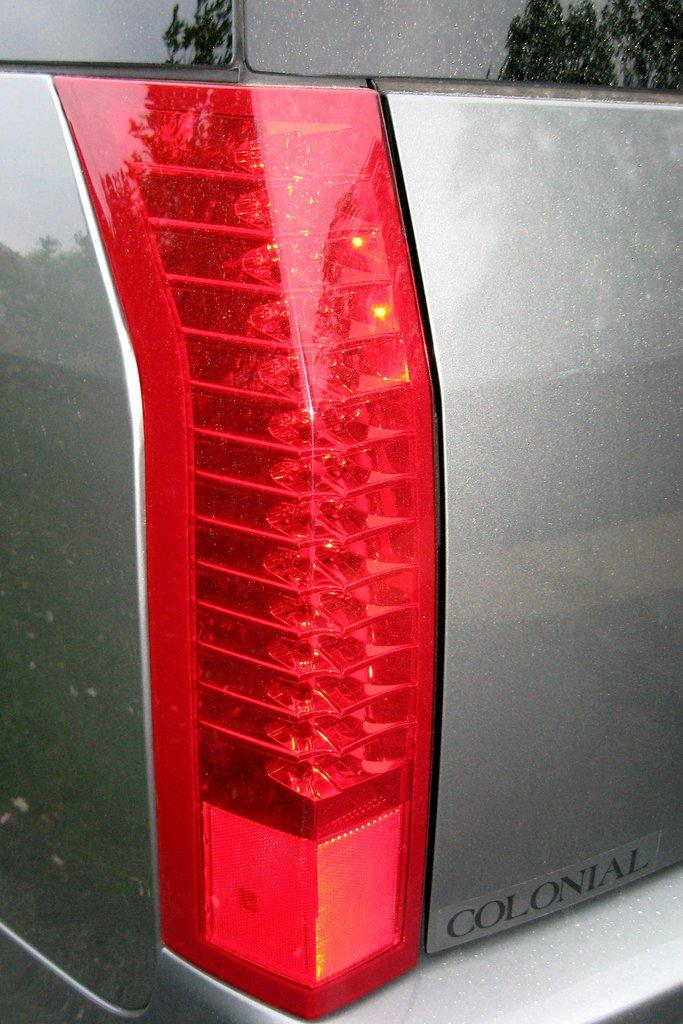What is the main subject of the image? The main subject of the image is the tail light of a vehicle. Can you describe the tail light in more detail? Unfortunately, the facts provided do not offer any additional details about the tail light. Is there any other part of the vehicle visible in the image? The facts provided do not mention any other parts of the vehicle being visible in the image. How many partners are present in the image? There are no partners present in the image, as it only features the tail light of a vehicle. Is there a field visible in the image? There is no field visible in the image; it only contains the tail light of a vehicle. 